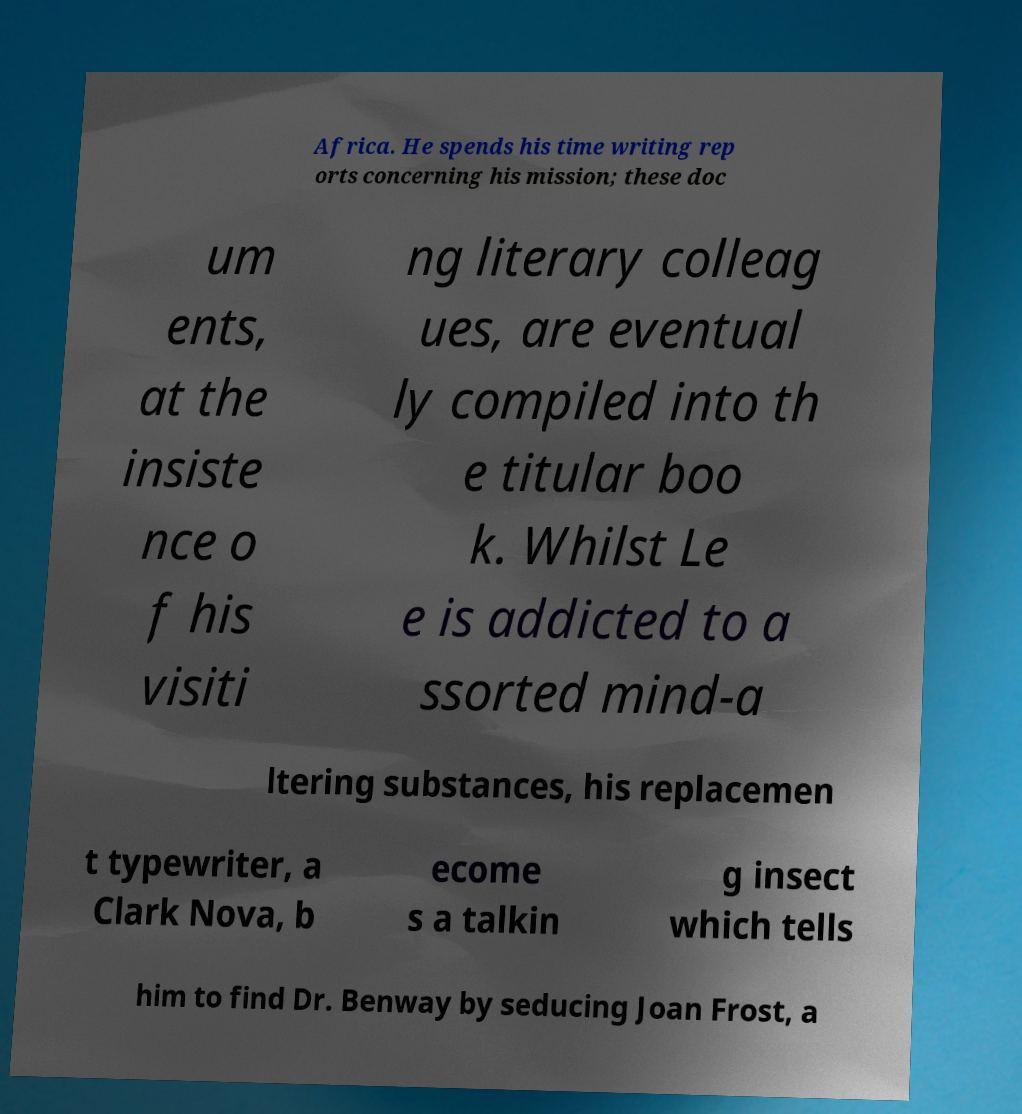I need the written content from this picture converted into text. Can you do that? Africa. He spends his time writing rep orts concerning his mission; these doc um ents, at the insiste nce o f his visiti ng literary colleag ues, are eventual ly compiled into th e titular boo k. Whilst Le e is addicted to a ssorted mind-a ltering substances, his replacemen t typewriter, a Clark Nova, b ecome s a talkin g insect which tells him to find Dr. Benway by seducing Joan Frost, a 